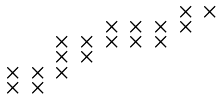<formula> <loc_0><loc_0><loc_500><loc_500>\begin{smallmatrix} & & & & & & & \times & \times \\ & & & & \times & \times & \times & \times & \\ & & \times & \times & \times & \times & \times \\ & & \times & \times \\ \times & \times & \times \\ \times & \times \end{smallmatrix}</formula> 